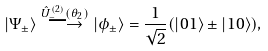<formula> <loc_0><loc_0><loc_500><loc_500>| \Psi _ { \pm } \rangle \overset { \hat { U } ^ { ( 2 ) } _ { - } ( \theta _ { 2 } ) } { \longrightarrow } | \phi _ { \pm } \rangle = \frac { 1 } { \sqrt { 2 } } ( | 0 1 \rangle \pm | 1 0 \rangle ) ,</formula> 